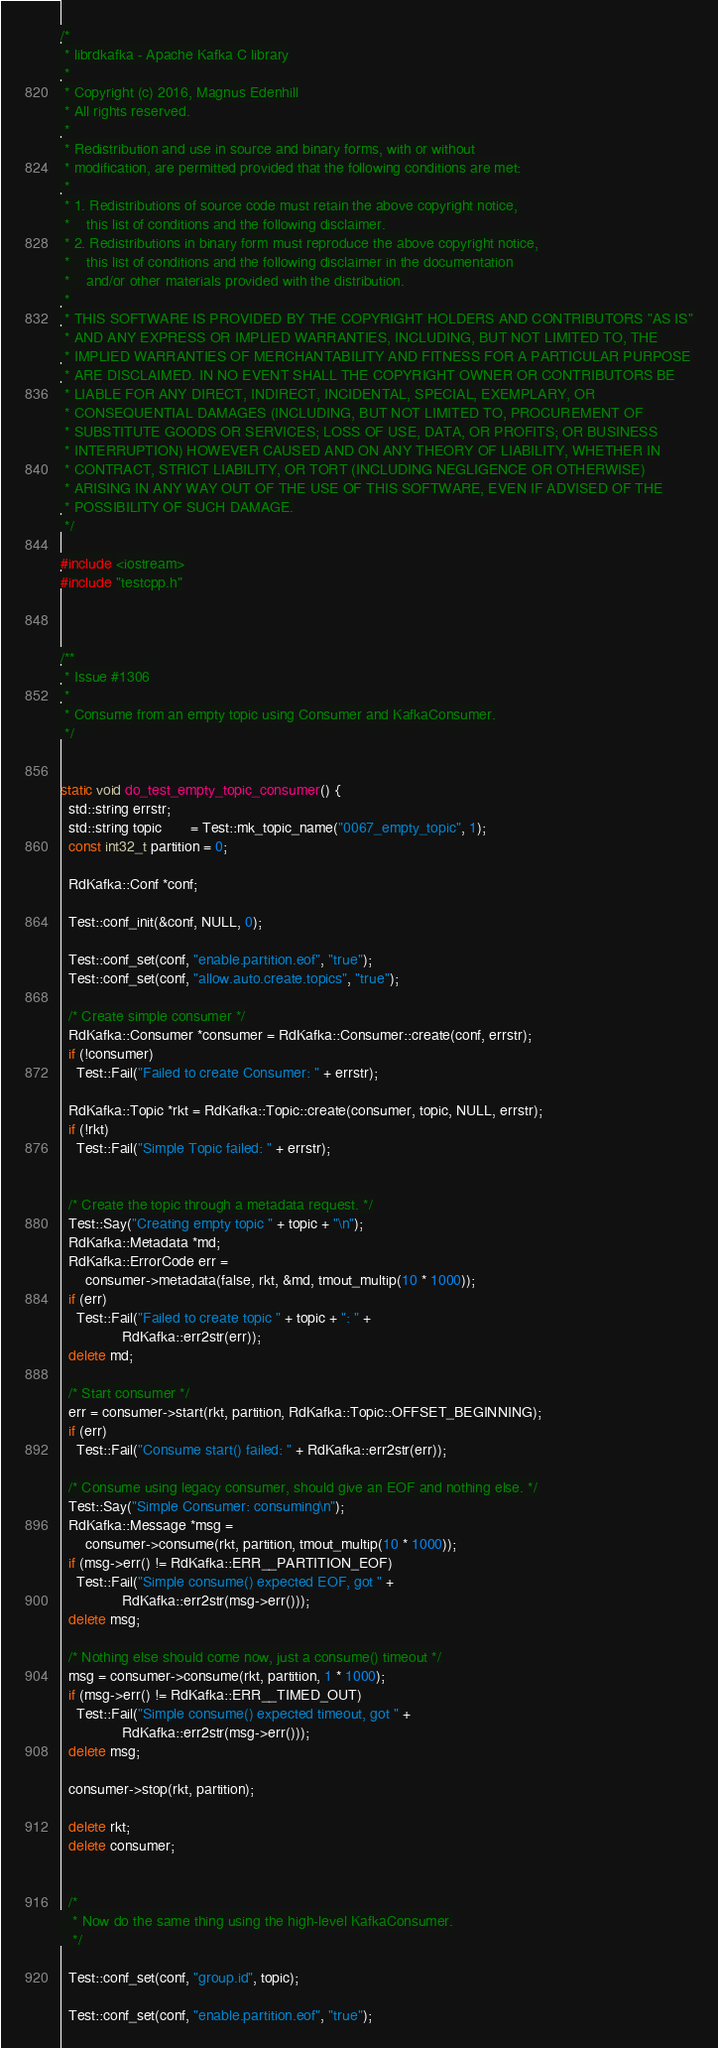Convert code to text. <code><loc_0><loc_0><loc_500><loc_500><_C++_>/*
 * librdkafka - Apache Kafka C library
 *
 * Copyright (c) 2016, Magnus Edenhill
 * All rights reserved.
 *
 * Redistribution and use in source and binary forms, with or without
 * modification, are permitted provided that the following conditions are met:
 *
 * 1. Redistributions of source code must retain the above copyright notice,
 *    this list of conditions and the following disclaimer.
 * 2. Redistributions in binary form must reproduce the above copyright notice,
 *    this list of conditions and the following disclaimer in the documentation
 *    and/or other materials provided with the distribution.
 *
 * THIS SOFTWARE IS PROVIDED BY THE COPYRIGHT HOLDERS AND CONTRIBUTORS "AS IS"
 * AND ANY EXPRESS OR IMPLIED WARRANTIES, INCLUDING, BUT NOT LIMITED TO, THE
 * IMPLIED WARRANTIES OF MERCHANTABILITY AND FITNESS FOR A PARTICULAR PURPOSE
 * ARE DISCLAIMED. IN NO EVENT SHALL THE COPYRIGHT OWNER OR CONTRIBUTORS BE
 * LIABLE FOR ANY DIRECT, INDIRECT, INCIDENTAL, SPECIAL, EXEMPLARY, OR
 * CONSEQUENTIAL DAMAGES (INCLUDING, BUT NOT LIMITED TO, PROCUREMENT OF
 * SUBSTITUTE GOODS OR SERVICES; LOSS OF USE, DATA, OR PROFITS; OR BUSINESS
 * INTERRUPTION) HOWEVER CAUSED AND ON ANY THEORY OF LIABILITY, WHETHER IN
 * CONTRACT, STRICT LIABILITY, OR TORT (INCLUDING NEGLIGENCE OR OTHERWISE)
 * ARISING IN ANY WAY OUT OF THE USE OF THIS SOFTWARE, EVEN IF ADVISED OF THE
 * POSSIBILITY OF SUCH DAMAGE.
 */

#include <iostream>
#include "testcpp.h"



/**
 * Issue #1306
 *
 * Consume from an empty topic using Consumer and KafkaConsumer.
 */


static void do_test_empty_topic_consumer() {
  std::string errstr;
  std::string topic       = Test::mk_topic_name("0067_empty_topic", 1);
  const int32_t partition = 0;

  RdKafka::Conf *conf;

  Test::conf_init(&conf, NULL, 0);

  Test::conf_set(conf, "enable.partition.eof", "true");
  Test::conf_set(conf, "allow.auto.create.topics", "true");

  /* Create simple consumer */
  RdKafka::Consumer *consumer = RdKafka::Consumer::create(conf, errstr);
  if (!consumer)
    Test::Fail("Failed to create Consumer: " + errstr);

  RdKafka::Topic *rkt = RdKafka::Topic::create(consumer, topic, NULL, errstr);
  if (!rkt)
    Test::Fail("Simple Topic failed: " + errstr);


  /* Create the topic through a metadata request. */
  Test::Say("Creating empty topic " + topic + "\n");
  RdKafka::Metadata *md;
  RdKafka::ErrorCode err =
      consumer->metadata(false, rkt, &md, tmout_multip(10 * 1000));
  if (err)
    Test::Fail("Failed to create topic " + topic + ": " +
               RdKafka::err2str(err));
  delete md;

  /* Start consumer */
  err = consumer->start(rkt, partition, RdKafka::Topic::OFFSET_BEGINNING);
  if (err)
    Test::Fail("Consume start() failed: " + RdKafka::err2str(err));

  /* Consume using legacy consumer, should give an EOF and nothing else. */
  Test::Say("Simple Consumer: consuming\n");
  RdKafka::Message *msg =
      consumer->consume(rkt, partition, tmout_multip(10 * 1000));
  if (msg->err() != RdKafka::ERR__PARTITION_EOF)
    Test::Fail("Simple consume() expected EOF, got " +
               RdKafka::err2str(msg->err()));
  delete msg;

  /* Nothing else should come now, just a consume() timeout */
  msg = consumer->consume(rkt, partition, 1 * 1000);
  if (msg->err() != RdKafka::ERR__TIMED_OUT)
    Test::Fail("Simple consume() expected timeout, got " +
               RdKafka::err2str(msg->err()));
  delete msg;

  consumer->stop(rkt, partition);

  delete rkt;
  delete consumer;


  /*
   * Now do the same thing using the high-level KafkaConsumer.
   */

  Test::conf_set(conf, "group.id", topic);

  Test::conf_set(conf, "enable.partition.eof", "true");</code> 